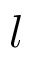<formula> <loc_0><loc_0><loc_500><loc_500>l</formula> 